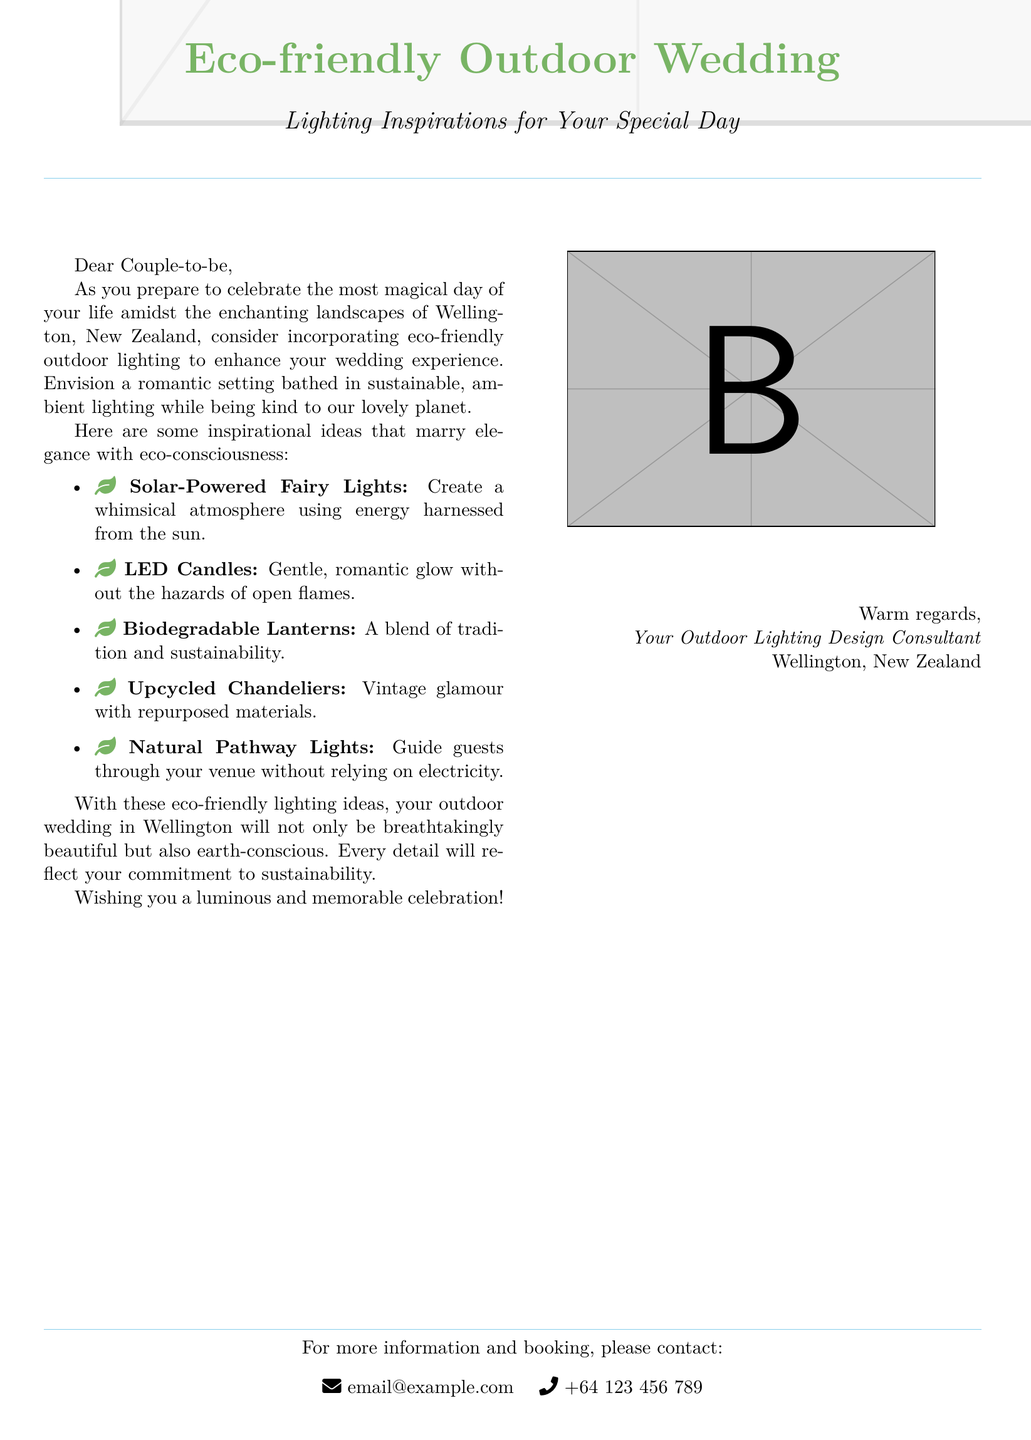What is the title of the document? The title is prominently displayed at the top of the document, introducing the theme of the content.
Answer: Eco-friendly Outdoor Wedding How many eco-friendly lighting ideas are listed? The document contains a list of five different eco-friendly lighting ideas provided for inspiration.
Answer: Five What is the focus color used in the document? The color that is consistently used throughout the document for headings and accents is described with its name.
Answer: Leaf green Which country is mentioned as the location for the wedding? The document specifically references the country where the wedding is advised to take place.
Answer: New Zealand What type of lighting is suggested for a romantic glow without open flames? The document describes a specific type of lighting that provides ambiance while ensuring safety.
Answer: LED Candles What is one eco-friendly lighting option that incorporates repurposed materials? The document mentions a particular lighting solution that emphasizes the use of previously used materials for decoration.
Answer: Upcycled Chandeliers What contact information is given for further inquiries? The document includes specific contact details for couples seeking more information or booking services.
Answer: email@example.com Who is the author of the document? The document concludes with a signature line that indicates the writer's profession and location.
Answer: Your Outdoor Lighting Design Consultant 